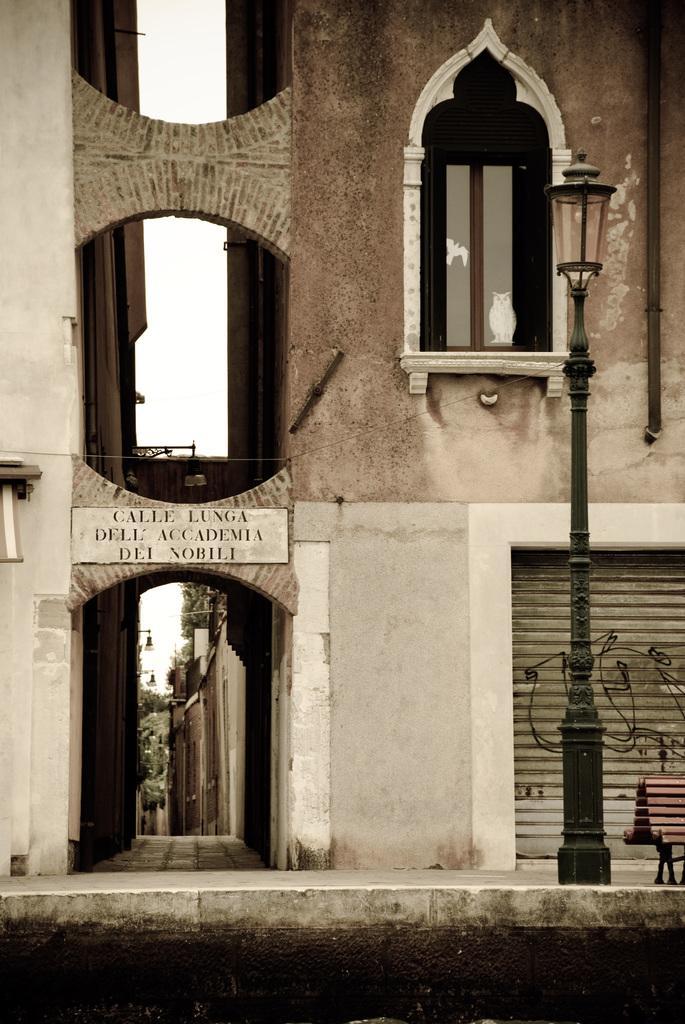Describe this image in one or two sentences. This image consists of a building along with the windows and a shutter. At the bottom, there is a pavement along with a pole. In the front, there is a board on the building. 